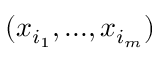Convert formula to latex. <formula><loc_0><loc_0><loc_500><loc_500>( x _ { i _ { 1 } } , \dots , x _ { i _ { m } } )</formula> 